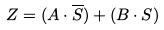<formula> <loc_0><loc_0><loc_500><loc_500>Z = ( A \cdot \overline { S } ) + ( B \cdot S )</formula> 